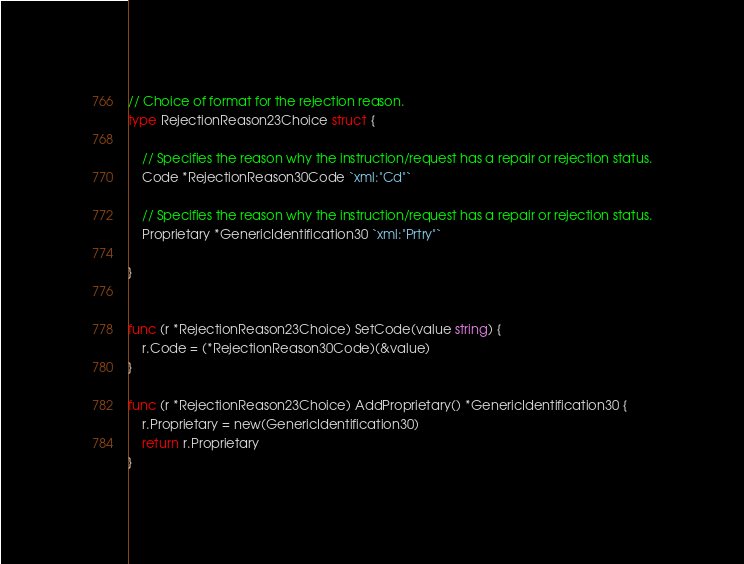<code> <loc_0><loc_0><loc_500><loc_500><_Go_>
// Choice of format for the rejection reason.
type RejectionReason23Choice struct {

	// Specifies the reason why the instruction/request has a repair or rejection status.
	Code *RejectionReason30Code `xml:"Cd"`

	// Specifies the reason why the instruction/request has a repair or rejection status.
	Proprietary *GenericIdentification30 `xml:"Prtry"`

}


func (r *RejectionReason23Choice) SetCode(value string) {
	r.Code = (*RejectionReason30Code)(&value)
}

func (r *RejectionReason23Choice) AddProprietary() *GenericIdentification30 {
	r.Proprietary = new(GenericIdentification30)
	return r.Proprietary
}

</code> 